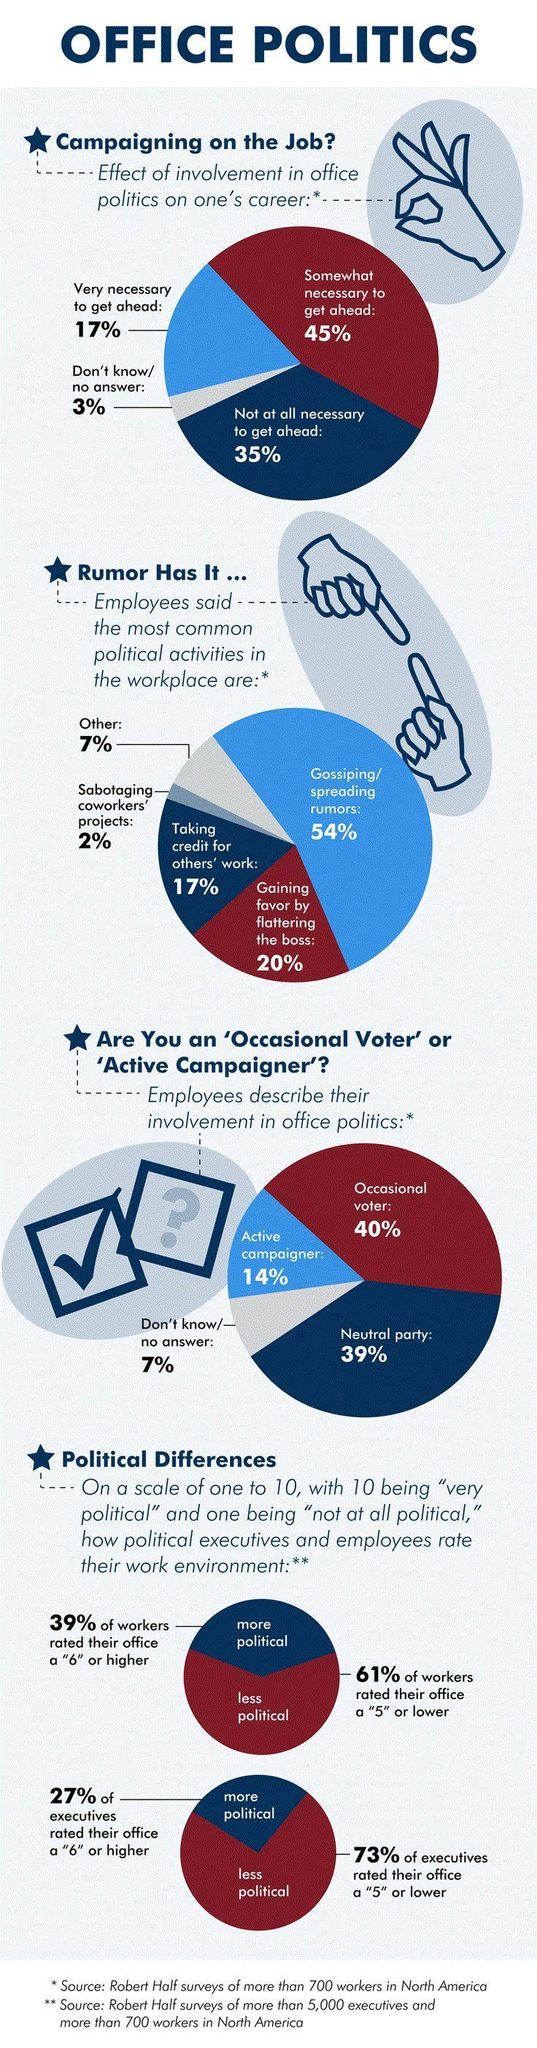How many employees feel that gaining favour by flattering the boss is the most common political activity in workplace
Answer the question with a short phrase. 20% What % feel that office politics is not at all necessary to get ahead 35% how do majority of the workers rate their work environment less political What do majority of the employees think the most common political activity in workplace is gossiping/spreading rumors What do majority of the people think about office politic on one's career somewhat necessary to get ahead 